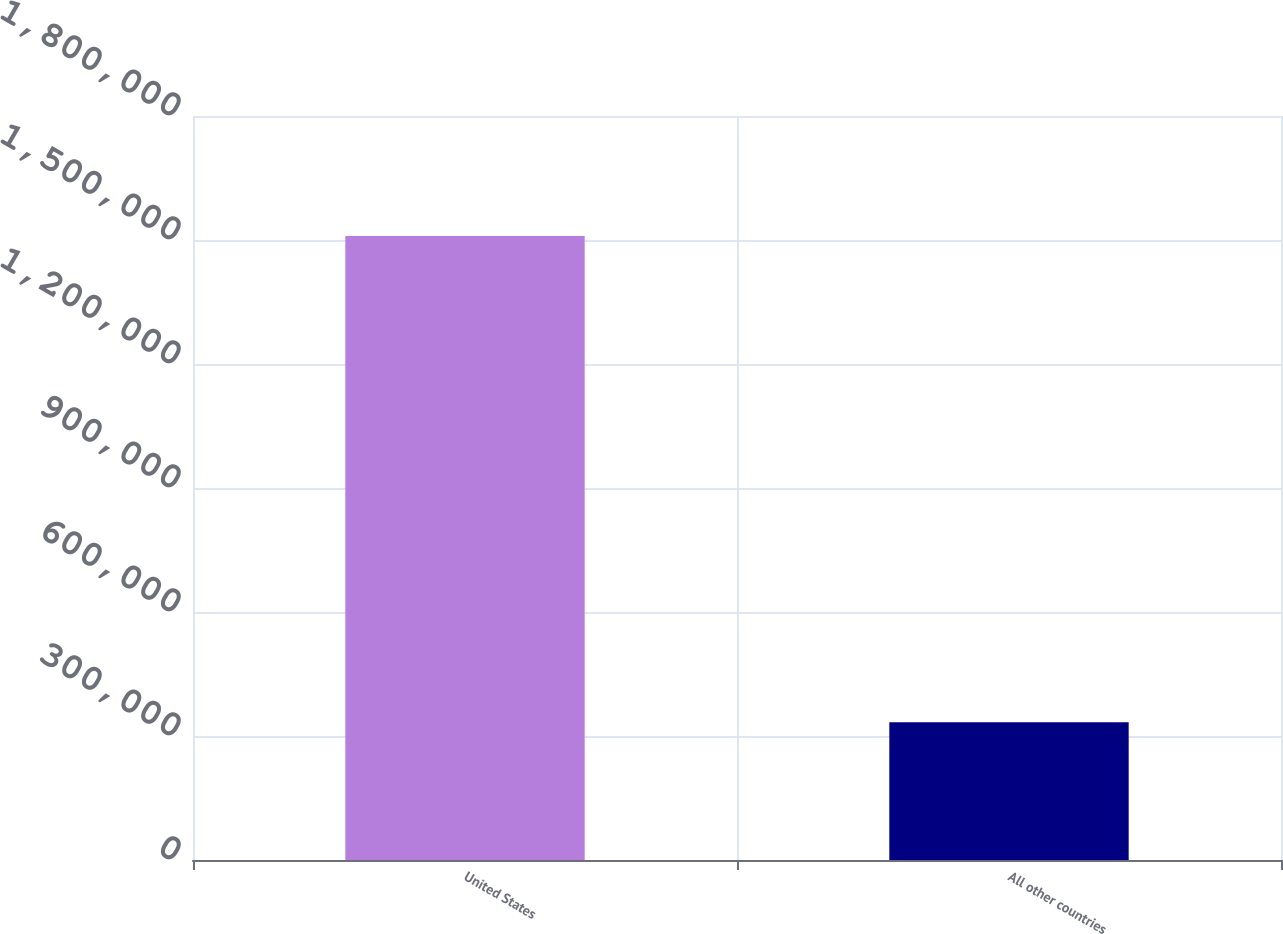Convert chart to OTSL. <chart><loc_0><loc_0><loc_500><loc_500><bar_chart><fcel>United States<fcel>All other countries<nl><fcel>1.50982e+06<fcel>333193<nl></chart> 